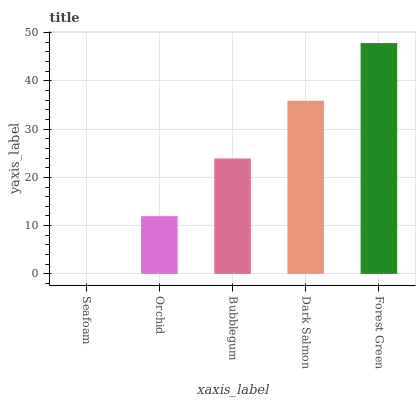Is Orchid the minimum?
Answer yes or no. No. Is Orchid the maximum?
Answer yes or no. No. Is Orchid greater than Seafoam?
Answer yes or no. Yes. Is Seafoam less than Orchid?
Answer yes or no. Yes. Is Seafoam greater than Orchid?
Answer yes or no. No. Is Orchid less than Seafoam?
Answer yes or no. No. Is Bubblegum the high median?
Answer yes or no. Yes. Is Bubblegum the low median?
Answer yes or no. Yes. Is Orchid the high median?
Answer yes or no. No. Is Dark Salmon the low median?
Answer yes or no. No. 